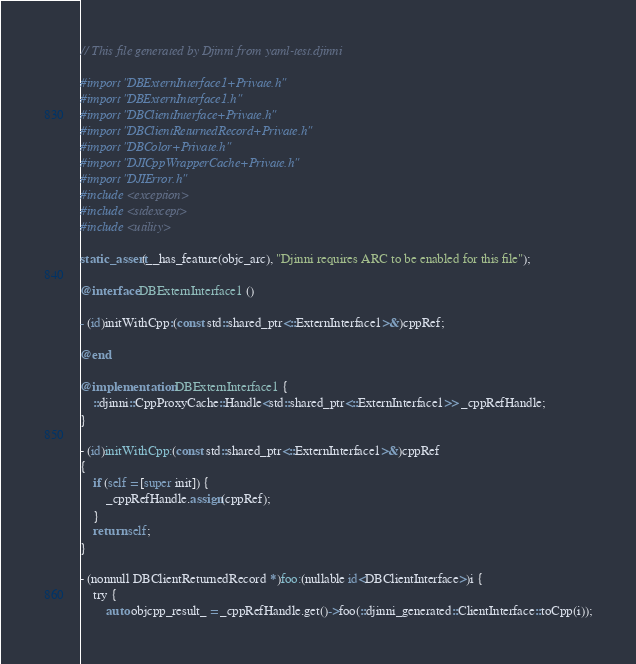Convert code to text. <code><loc_0><loc_0><loc_500><loc_500><_ObjectiveC_>// This file generated by Djinni from yaml-test.djinni

#import "DBExternInterface1+Private.h"
#import "DBExternInterface1.h"
#import "DBClientInterface+Private.h"
#import "DBClientReturnedRecord+Private.h"
#import "DBColor+Private.h"
#import "DJICppWrapperCache+Private.h"
#import "DJIError.h"
#include <exception>
#include <stdexcept>
#include <utility>

static_assert(__has_feature(objc_arc), "Djinni requires ARC to be enabled for this file");

@interface DBExternInterface1 ()

- (id)initWithCpp:(const std::shared_ptr<::ExternInterface1>&)cppRef;

@end

@implementation DBExternInterface1 {
    ::djinni::CppProxyCache::Handle<std::shared_ptr<::ExternInterface1>> _cppRefHandle;
}

- (id)initWithCpp:(const std::shared_ptr<::ExternInterface1>&)cppRef
{
    if (self = [super init]) {
        _cppRefHandle.assign(cppRef);
    }
    return self;
}

- (nonnull DBClientReturnedRecord *)foo:(nullable id<DBClientInterface>)i {
    try {
        auto objcpp_result_ = _cppRefHandle.get()->foo(::djinni_generated::ClientInterface::toCpp(i));</code> 